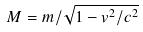<formula> <loc_0><loc_0><loc_500><loc_500>M = m / \sqrt { 1 - v ^ { 2 } / c ^ { 2 } }</formula> 